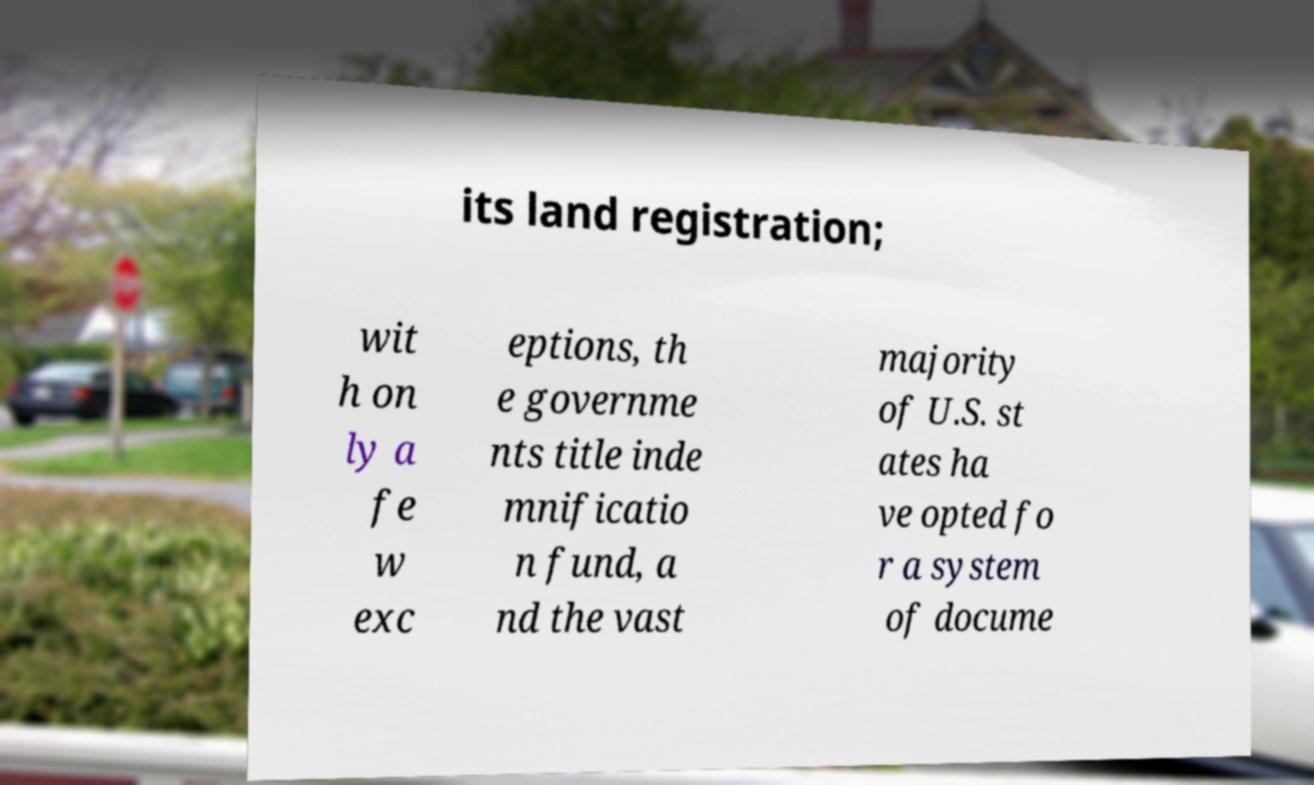Can you accurately transcribe the text from the provided image for me? its land registration; wit h on ly a fe w exc eptions, th e governme nts title inde mnificatio n fund, a nd the vast majority of U.S. st ates ha ve opted fo r a system of docume 